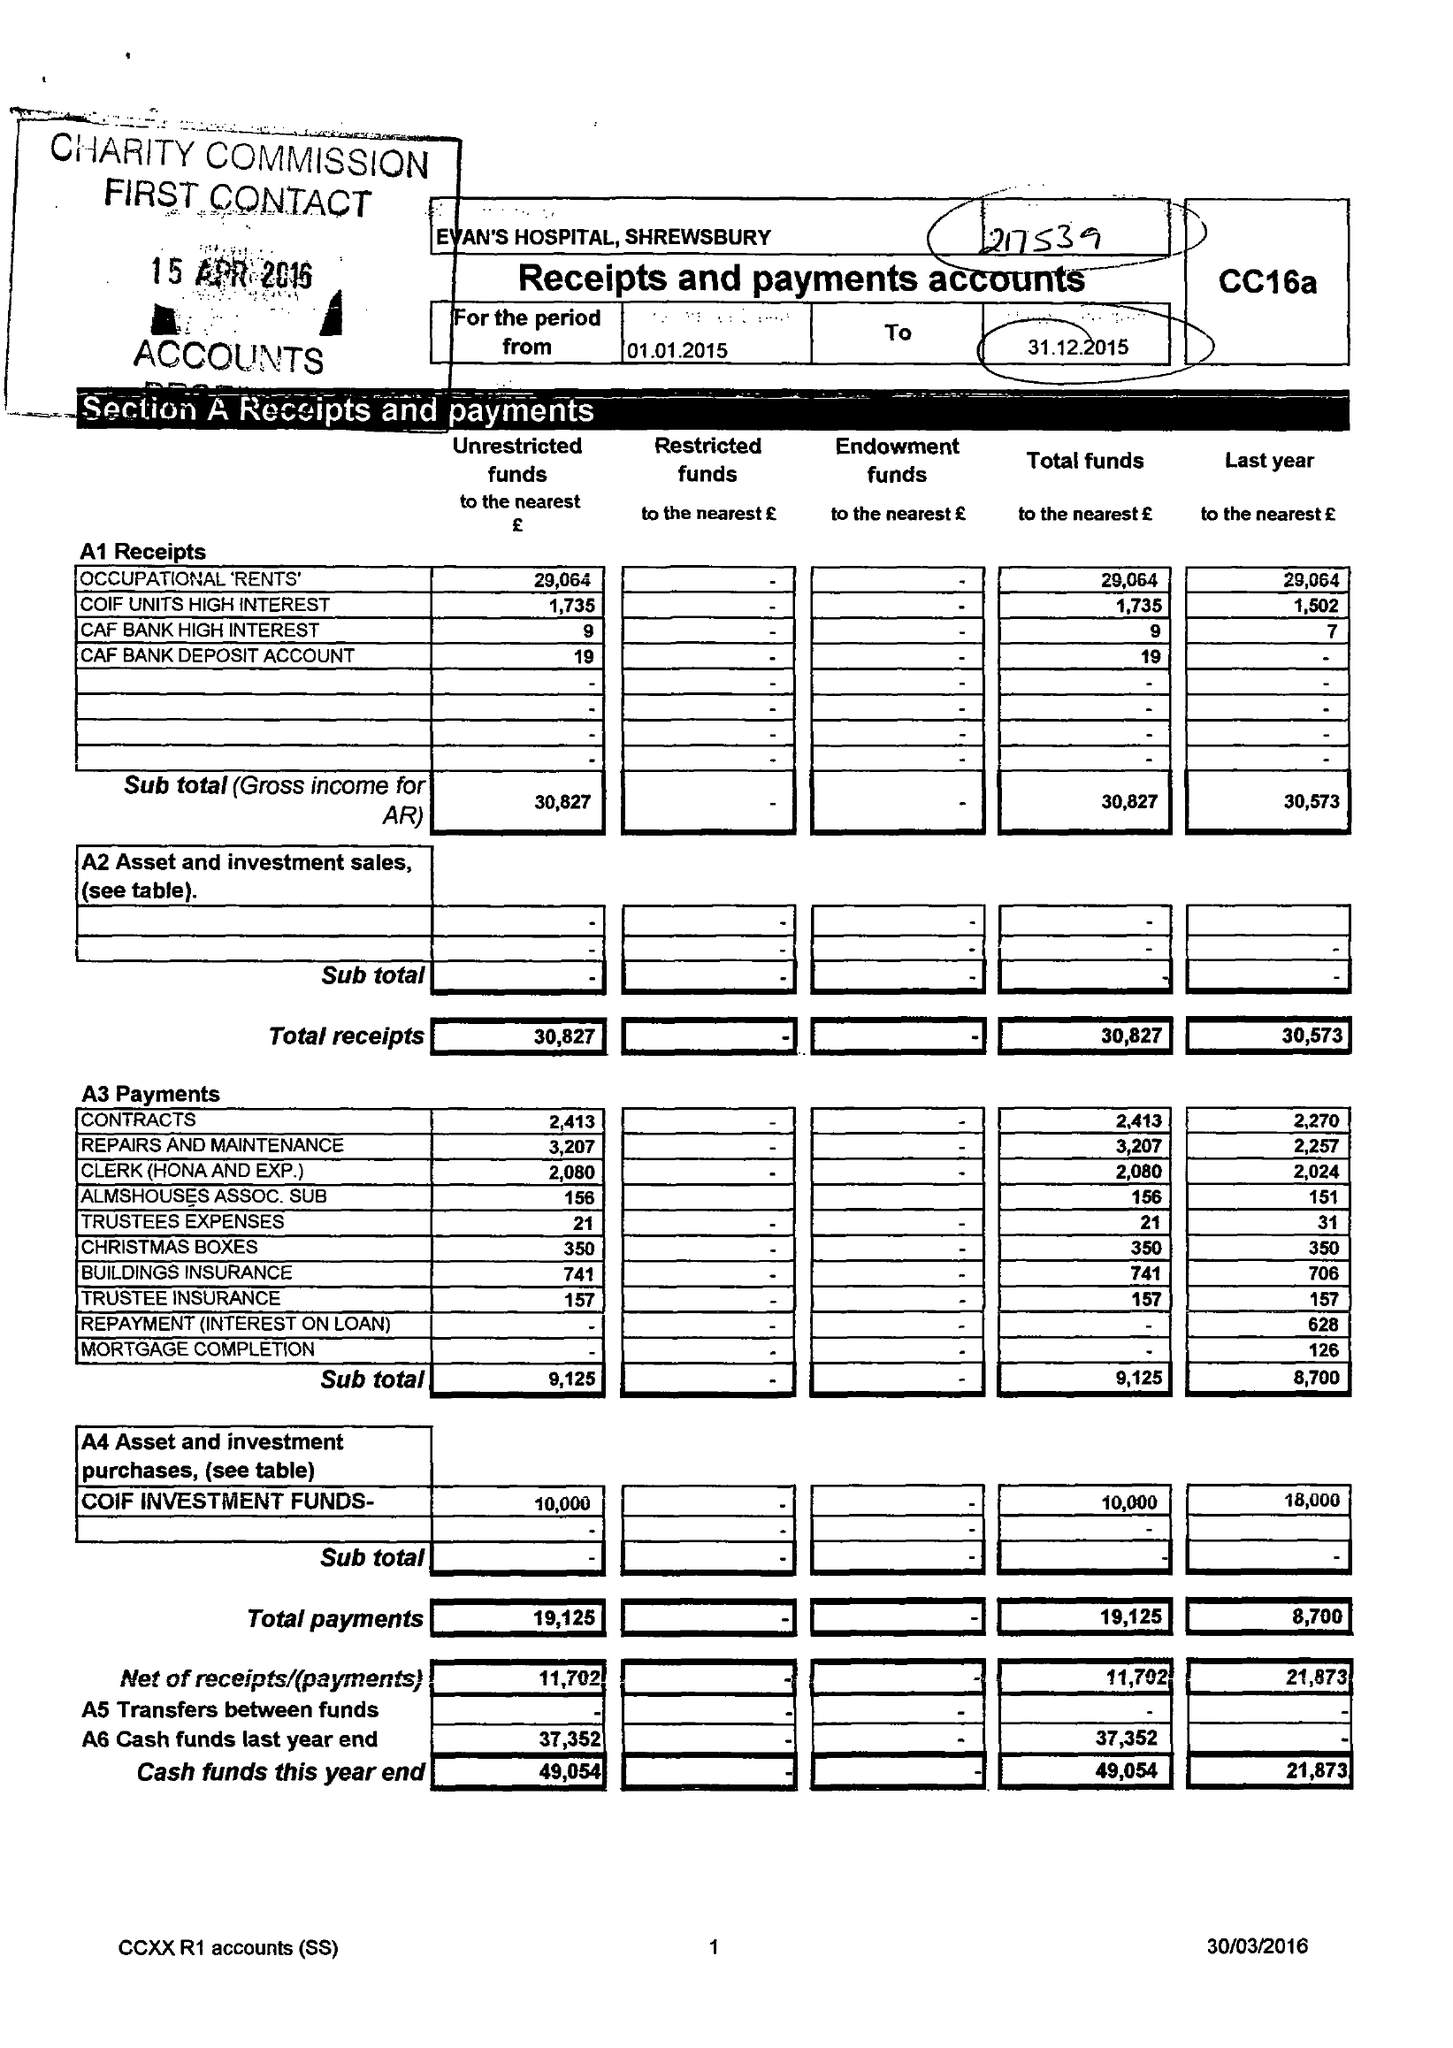What is the value for the address__postcode?
Answer the question using a single word or phrase. SY3 9QG 